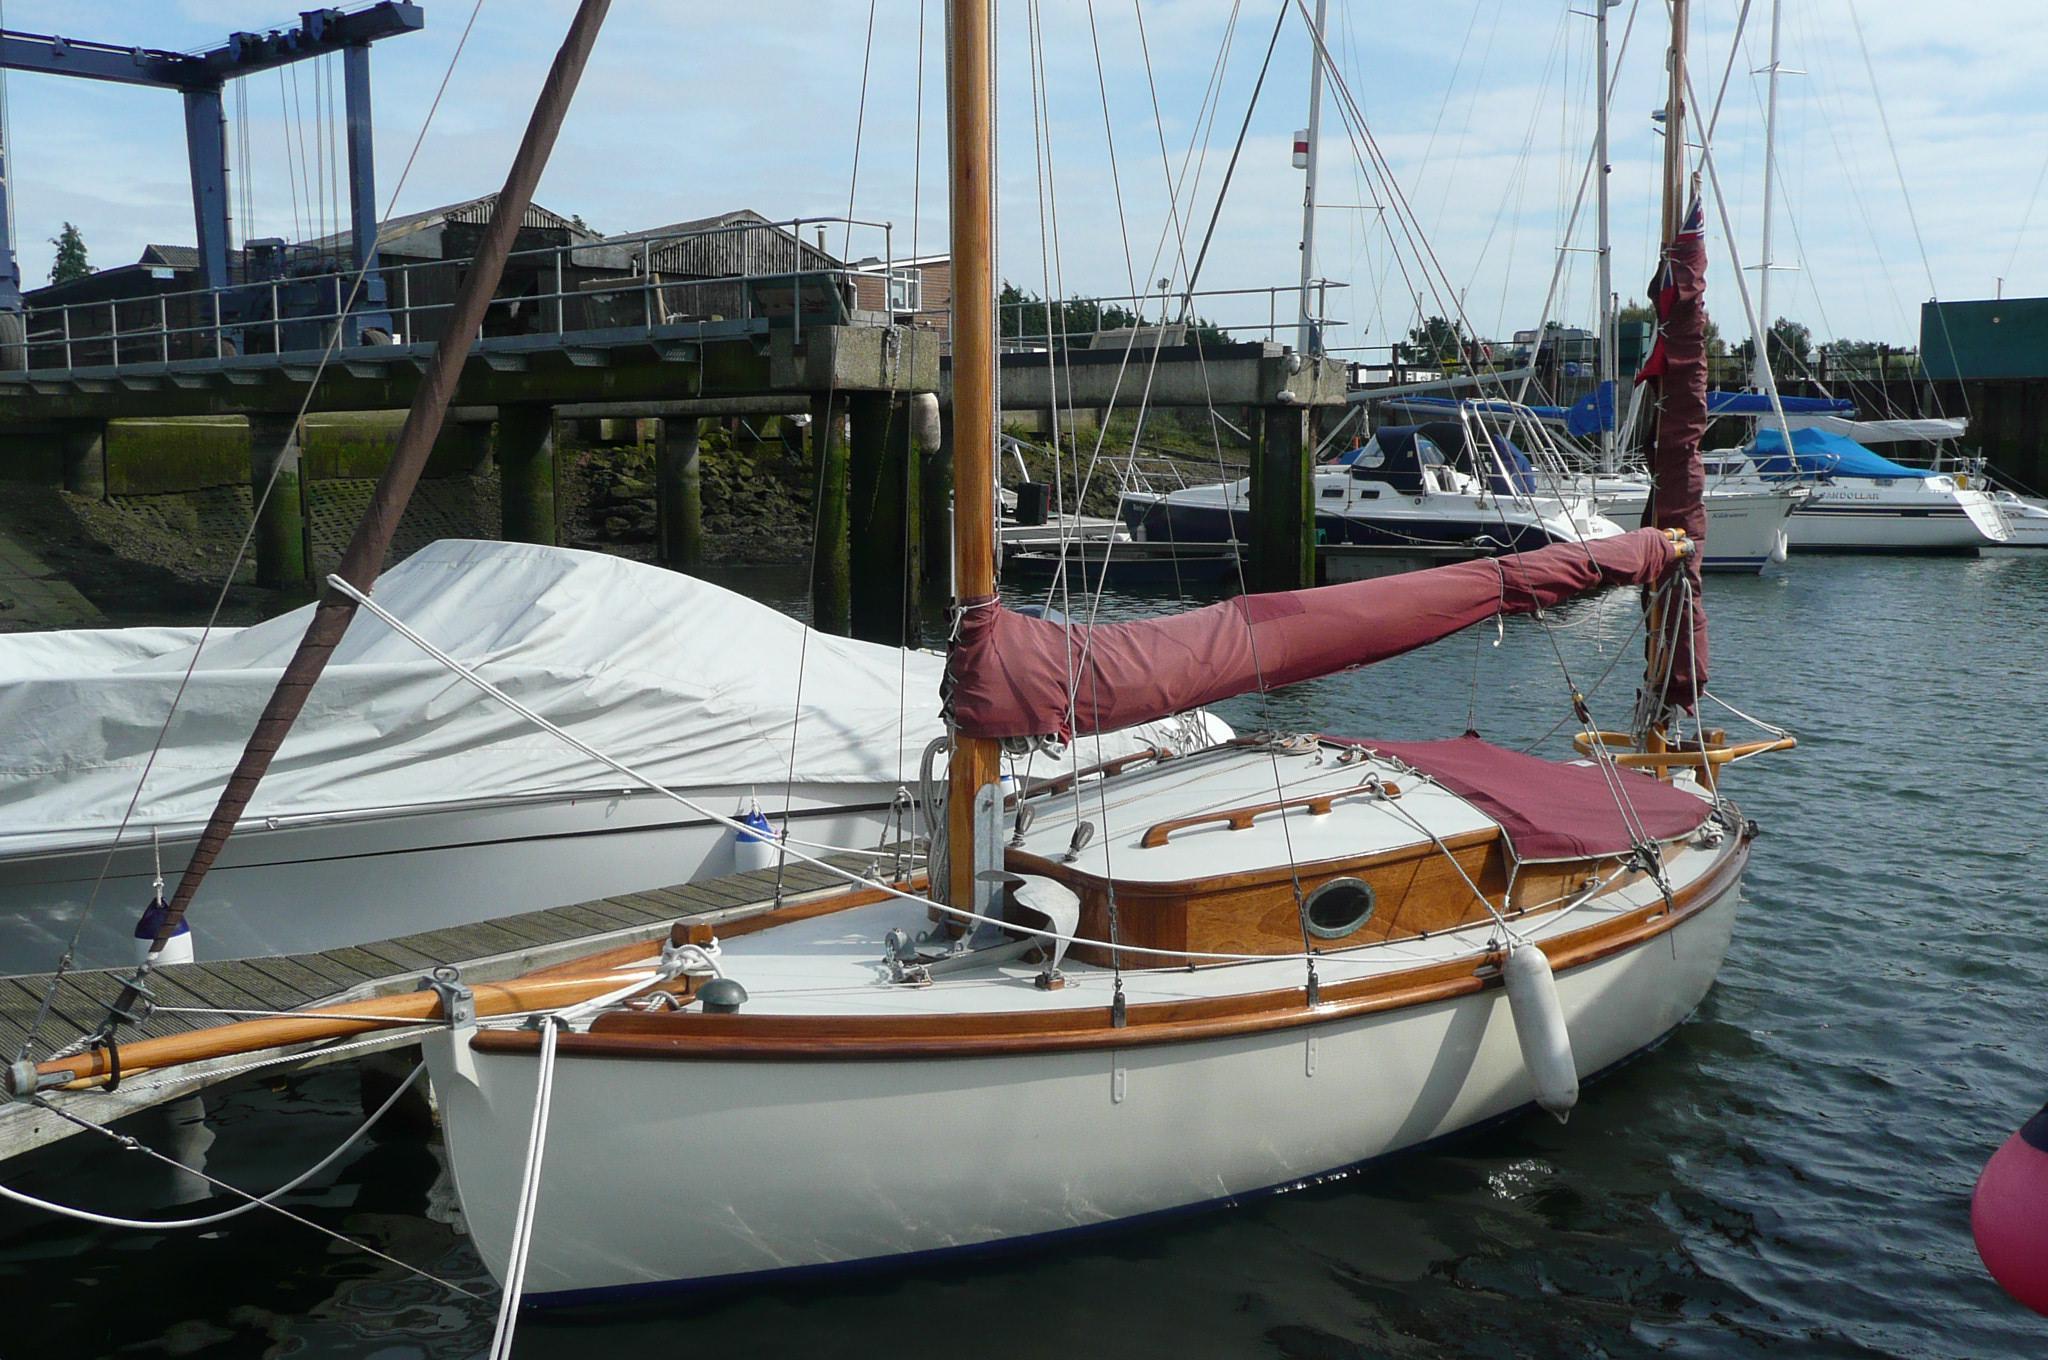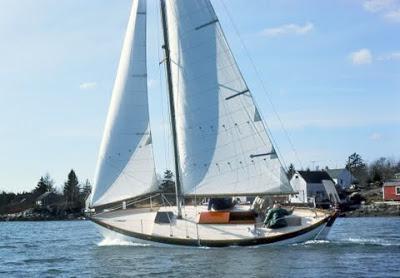The first image is the image on the left, the second image is the image on the right. Given the left and right images, does the statement "An image shows a white-sailed boat creating white spray as it moves through the water." hold true? Answer yes or no. Yes. The first image is the image on the left, the second image is the image on the right. Given the left and right images, does the statement "There is a docked boat in the water whos sail is not deployed." hold true? Answer yes or no. Yes. 